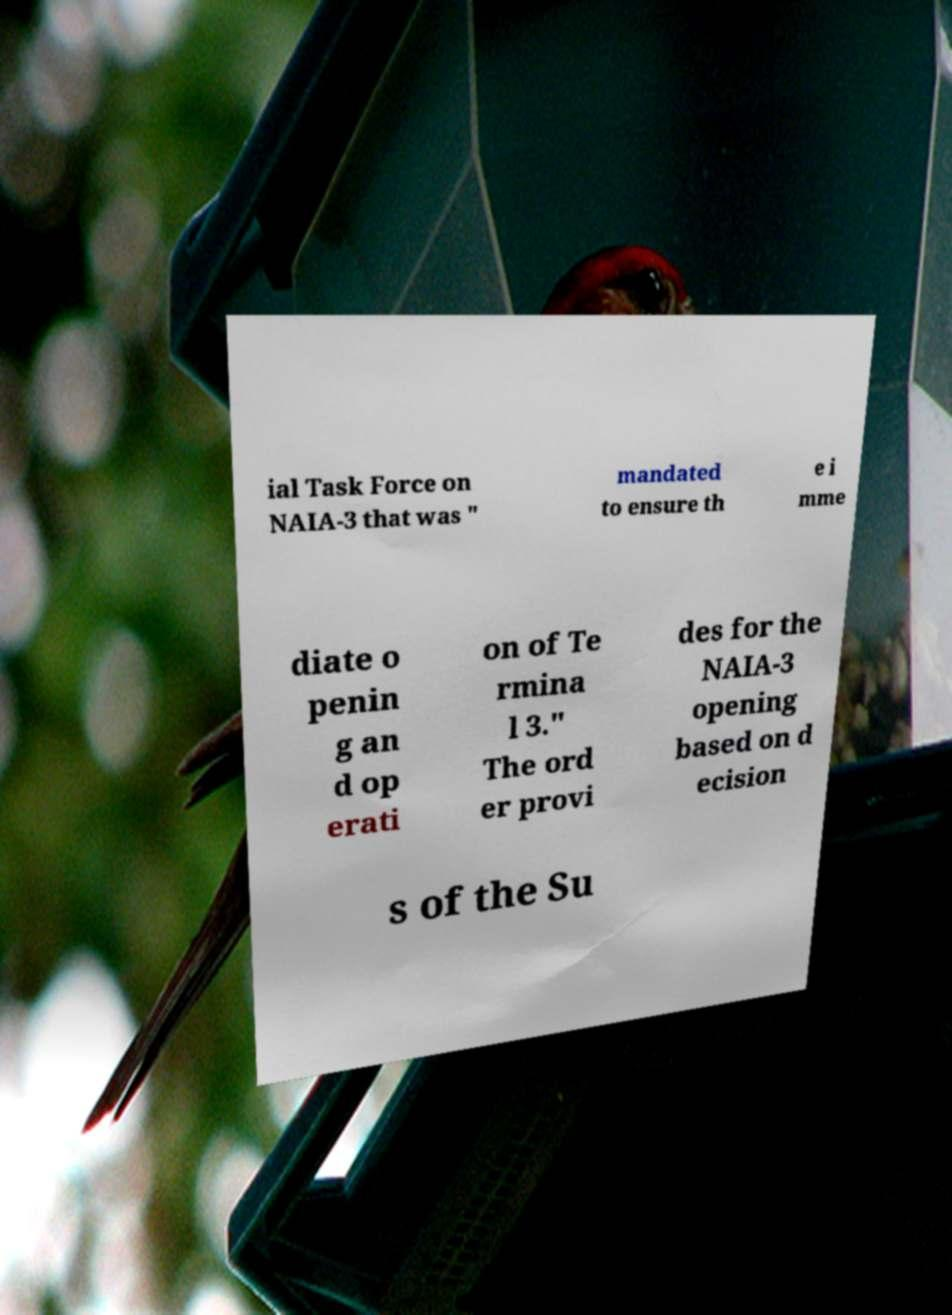Can you accurately transcribe the text from the provided image for me? ial Task Force on NAIA-3 that was " mandated to ensure th e i mme diate o penin g an d op erati on of Te rmina l 3." The ord er provi des for the NAIA-3 opening based on d ecision s of the Su 